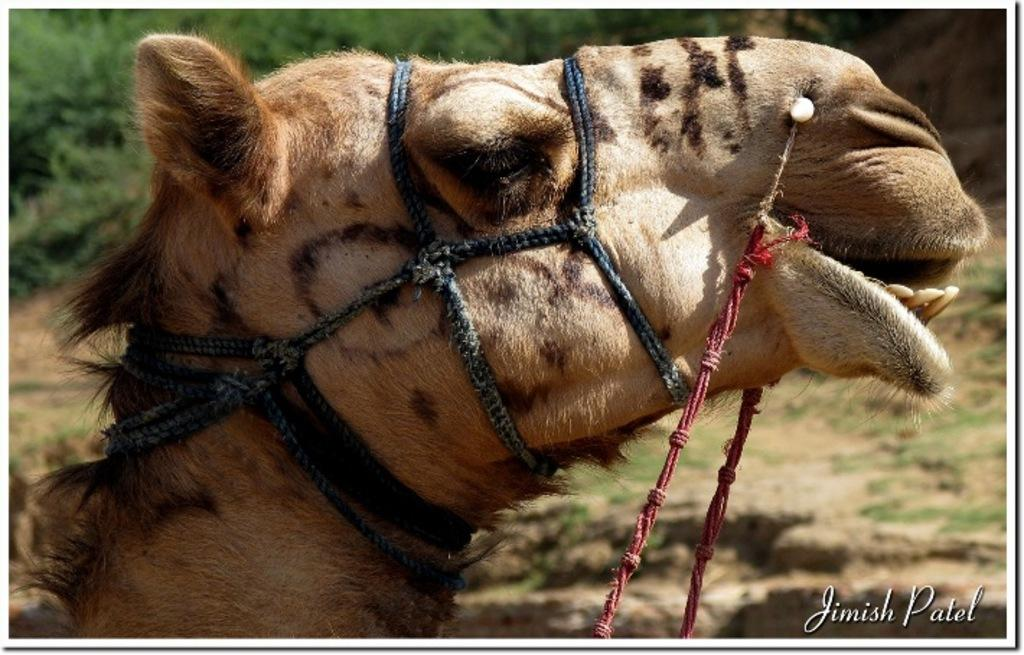What is the main subject of the image? There is a camel's face in the image. What can be seen in the background of the image? There are trees in the background of the image. Is there any text or logo visible in the image? Yes, there is a watermark in the bottom right corner of the image. What else can be seen in the image besides the camel's face and trees? Ropes are present in the image. What color is the duck that is painted on the camel's face in the image? There is no duck painted on the camel's face in the image. 